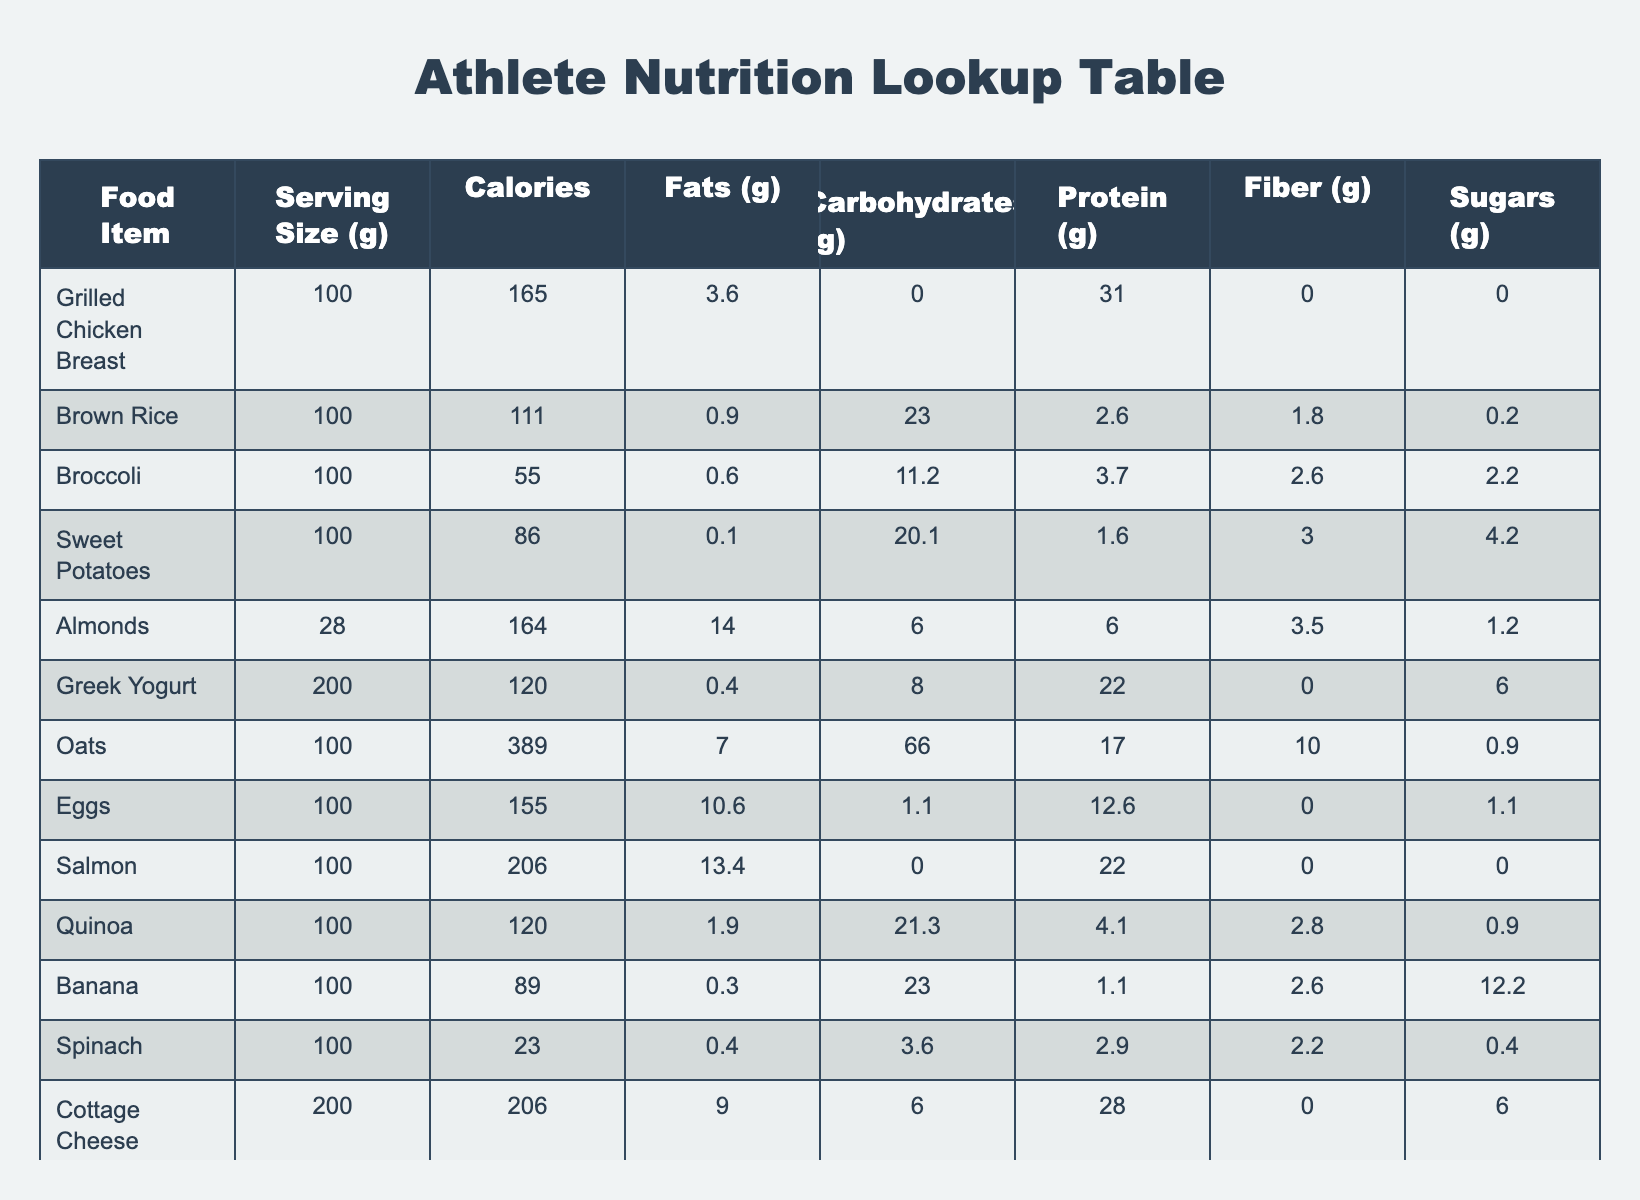What food item has the highest calorie content? By examining the "Calories" column, we see that Oats have the highest value of 389 kcal.
Answer: Oats How many grams of protein are in Greek Yogurt? Looking at the row for Greek Yogurt, the "Protein" column shows a value of 22 grams.
Answer: 22 grams What is the total carbohydrate content in Chickpeas and Sweet Potatoes together? Adding the "Carbohydrates" values from both rows: Chickpeas has 27.4 grams and Sweet Potatoes has 20.1 grams. Total: 27.4 + 20.1 = 47.5 grams.
Answer: 47.5 grams Is Salmon a good source of fiber? In the table, the "Fiber" column for Salmon shows 0 grams, indicating that it is not a good source of fiber.
Answer: No Which food item contains the most fats per serving? Inspecting the "Fats" column, Almonds have the highest fat content at 14 grams per 28 grams serving.
Answer: Almonds 